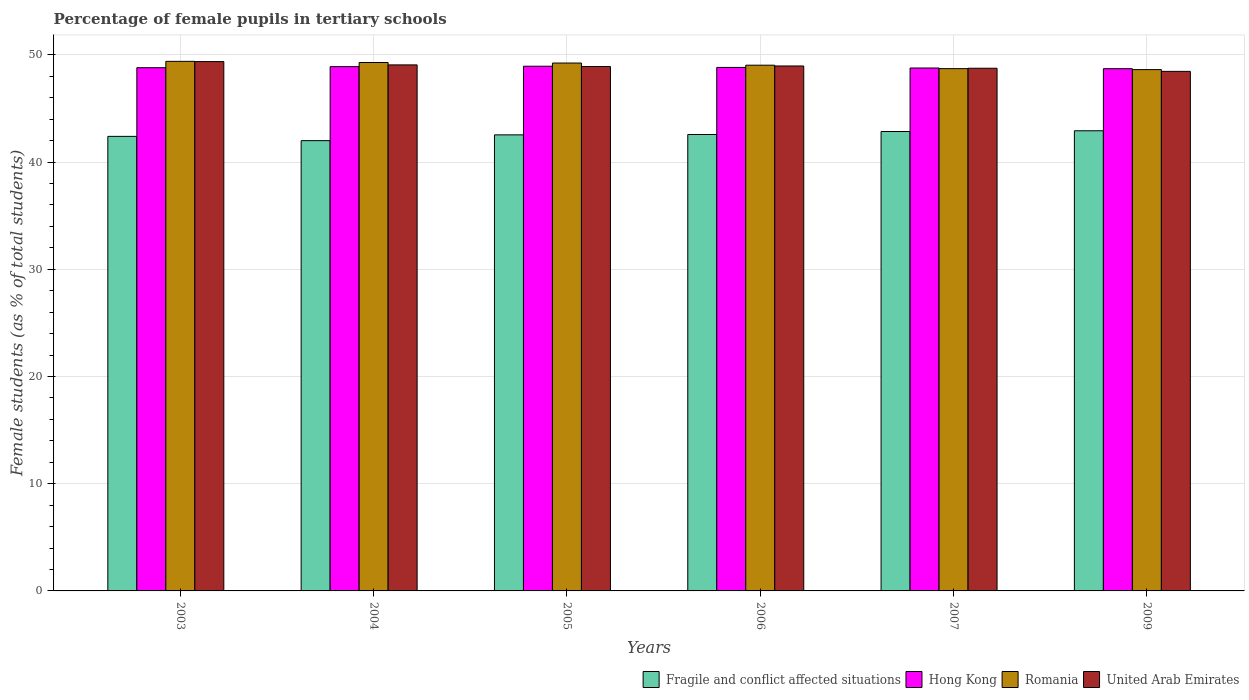How many groups of bars are there?
Keep it short and to the point. 6. Are the number of bars on each tick of the X-axis equal?
Offer a terse response. Yes. How many bars are there on the 3rd tick from the right?
Provide a succinct answer. 4. What is the percentage of female pupils in tertiary schools in Fragile and conflict affected situations in 2005?
Offer a very short reply. 42.53. Across all years, what is the maximum percentage of female pupils in tertiary schools in Romania?
Provide a succinct answer. 49.39. Across all years, what is the minimum percentage of female pupils in tertiary schools in Romania?
Make the answer very short. 48.62. In which year was the percentage of female pupils in tertiary schools in Romania maximum?
Provide a succinct answer. 2003. In which year was the percentage of female pupils in tertiary schools in United Arab Emirates minimum?
Offer a very short reply. 2009. What is the total percentage of female pupils in tertiary schools in Romania in the graph?
Your answer should be very brief. 294.27. What is the difference between the percentage of female pupils in tertiary schools in Hong Kong in 2006 and that in 2007?
Make the answer very short. 0.06. What is the difference between the percentage of female pupils in tertiary schools in United Arab Emirates in 2003 and the percentage of female pupils in tertiary schools in Fragile and conflict affected situations in 2005?
Your answer should be compact. 6.83. What is the average percentage of female pupils in tertiary schools in Romania per year?
Provide a short and direct response. 49.04. In the year 2004, what is the difference between the percentage of female pupils in tertiary schools in Fragile and conflict affected situations and percentage of female pupils in tertiary schools in Hong Kong?
Ensure brevity in your answer.  -6.9. In how many years, is the percentage of female pupils in tertiary schools in Fragile and conflict affected situations greater than 48 %?
Your answer should be compact. 0. What is the ratio of the percentage of female pupils in tertiary schools in Romania in 2003 to that in 2009?
Ensure brevity in your answer.  1.02. Is the percentage of female pupils in tertiary schools in Fragile and conflict affected situations in 2003 less than that in 2009?
Keep it short and to the point. Yes. What is the difference between the highest and the second highest percentage of female pupils in tertiary schools in Fragile and conflict affected situations?
Offer a very short reply. 0.07. What is the difference between the highest and the lowest percentage of female pupils in tertiary schools in Romania?
Your answer should be very brief. 0.77. Is the sum of the percentage of female pupils in tertiary schools in United Arab Emirates in 2006 and 2007 greater than the maximum percentage of female pupils in tertiary schools in Hong Kong across all years?
Provide a short and direct response. Yes. What does the 3rd bar from the left in 2007 represents?
Your answer should be very brief. Romania. What does the 2nd bar from the right in 2004 represents?
Provide a succinct answer. Romania. How many bars are there?
Make the answer very short. 24. Are all the bars in the graph horizontal?
Your response must be concise. No. Does the graph contain any zero values?
Ensure brevity in your answer.  No. Does the graph contain grids?
Your response must be concise. Yes. Where does the legend appear in the graph?
Give a very brief answer. Bottom right. How many legend labels are there?
Keep it short and to the point. 4. What is the title of the graph?
Offer a terse response. Percentage of female pupils in tertiary schools. What is the label or title of the X-axis?
Your answer should be very brief. Years. What is the label or title of the Y-axis?
Offer a very short reply. Female students (as % of total students). What is the Female students (as % of total students) in Fragile and conflict affected situations in 2003?
Your response must be concise. 42.39. What is the Female students (as % of total students) of Hong Kong in 2003?
Provide a short and direct response. 48.8. What is the Female students (as % of total students) in Romania in 2003?
Provide a succinct answer. 49.39. What is the Female students (as % of total students) in United Arab Emirates in 2003?
Give a very brief answer. 49.37. What is the Female students (as % of total students) in Fragile and conflict affected situations in 2004?
Provide a succinct answer. 42. What is the Female students (as % of total students) in Hong Kong in 2004?
Ensure brevity in your answer.  48.9. What is the Female students (as % of total students) in Romania in 2004?
Make the answer very short. 49.28. What is the Female students (as % of total students) in United Arab Emirates in 2004?
Your response must be concise. 49.06. What is the Female students (as % of total students) in Fragile and conflict affected situations in 2005?
Your answer should be compact. 42.53. What is the Female students (as % of total students) in Hong Kong in 2005?
Offer a very short reply. 48.94. What is the Female students (as % of total students) in Romania in 2005?
Offer a terse response. 49.23. What is the Female students (as % of total students) in United Arab Emirates in 2005?
Your answer should be very brief. 48.91. What is the Female students (as % of total students) in Fragile and conflict affected situations in 2006?
Offer a terse response. 42.57. What is the Female students (as % of total students) in Hong Kong in 2006?
Make the answer very short. 48.82. What is the Female students (as % of total students) in Romania in 2006?
Offer a very short reply. 49.03. What is the Female students (as % of total students) of United Arab Emirates in 2006?
Make the answer very short. 48.96. What is the Female students (as % of total students) in Fragile and conflict affected situations in 2007?
Your answer should be compact. 42.85. What is the Female students (as % of total students) in Hong Kong in 2007?
Your response must be concise. 48.77. What is the Female students (as % of total students) of Romania in 2007?
Offer a very short reply. 48.71. What is the Female students (as % of total students) in United Arab Emirates in 2007?
Ensure brevity in your answer.  48.75. What is the Female students (as % of total students) of Fragile and conflict affected situations in 2009?
Your answer should be compact. 42.92. What is the Female students (as % of total students) of Hong Kong in 2009?
Make the answer very short. 48.71. What is the Female students (as % of total students) in Romania in 2009?
Provide a short and direct response. 48.62. What is the Female students (as % of total students) in United Arab Emirates in 2009?
Provide a succinct answer. 48.46. Across all years, what is the maximum Female students (as % of total students) of Fragile and conflict affected situations?
Your response must be concise. 42.92. Across all years, what is the maximum Female students (as % of total students) of Hong Kong?
Keep it short and to the point. 48.94. Across all years, what is the maximum Female students (as % of total students) in Romania?
Keep it short and to the point. 49.39. Across all years, what is the maximum Female students (as % of total students) of United Arab Emirates?
Offer a very short reply. 49.37. Across all years, what is the minimum Female students (as % of total students) of Fragile and conflict affected situations?
Offer a very short reply. 42. Across all years, what is the minimum Female students (as % of total students) in Hong Kong?
Your response must be concise. 48.71. Across all years, what is the minimum Female students (as % of total students) in Romania?
Provide a short and direct response. 48.62. Across all years, what is the minimum Female students (as % of total students) in United Arab Emirates?
Ensure brevity in your answer.  48.46. What is the total Female students (as % of total students) of Fragile and conflict affected situations in the graph?
Offer a very short reply. 255.25. What is the total Female students (as % of total students) in Hong Kong in the graph?
Make the answer very short. 292.93. What is the total Female students (as % of total students) of Romania in the graph?
Provide a succinct answer. 294.27. What is the total Female students (as % of total students) of United Arab Emirates in the graph?
Your response must be concise. 293.5. What is the difference between the Female students (as % of total students) of Fragile and conflict affected situations in 2003 and that in 2004?
Offer a very short reply. 0.4. What is the difference between the Female students (as % of total students) of Hong Kong in 2003 and that in 2004?
Your response must be concise. -0.1. What is the difference between the Female students (as % of total students) of Romania in 2003 and that in 2004?
Your answer should be compact. 0.11. What is the difference between the Female students (as % of total students) of United Arab Emirates in 2003 and that in 2004?
Offer a very short reply. 0.31. What is the difference between the Female students (as % of total students) in Fragile and conflict affected situations in 2003 and that in 2005?
Offer a very short reply. -0.14. What is the difference between the Female students (as % of total students) of Hong Kong in 2003 and that in 2005?
Your answer should be very brief. -0.14. What is the difference between the Female students (as % of total students) of Romania in 2003 and that in 2005?
Give a very brief answer. 0.16. What is the difference between the Female students (as % of total students) of United Arab Emirates in 2003 and that in 2005?
Give a very brief answer. 0.46. What is the difference between the Female students (as % of total students) in Fragile and conflict affected situations in 2003 and that in 2006?
Make the answer very short. -0.17. What is the difference between the Female students (as % of total students) in Hong Kong in 2003 and that in 2006?
Your answer should be very brief. -0.03. What is the difference between the Female students (as % of total students) of Romania in 2003 and that in 2006?
Offer a very short reply. 0.36. What is the difference between the Female students (as % of total students) in United Arab Emirates in 2003 and that in 2006?
Give a very brief answer. 0.41. What is the difference between the Female students (as % of total students) in Fragile and conflict affected situations in 2003 and that in 2007?
Provide a short and direct response. -0.45. What is the difference between the Female students (as % of total students) of Hong Kong in 2003 and that in 2007?
Give a very brief answer. 0.03. What is the difference between the Female students (as % of total students) of Romania in 2003 and that in 2007?
Provide a succinct answer. 0.68. What is the difference between the Female students (as % of total students) of United Arab Emirates in 2003 and that in 2007?
Keep it short and to the point. 0.62. What is the difference between the Female students (as % of total students) of Fragile and conflict affected situations in 2003 and that in 2009?
Keep it short and to the point. -0.52. What is the difference between the Female students (as % of total students) in Hong Kong in 2003 and that in 2009?
Ensure brevity in your answer.  0.09. What is the difference between the Female students (as % of total students) in Romania in 2003 and that in 2009?
Your response must be concise. 0.77. What is the difference between the Female students (as % of total students) of United Arab Emirates in 2003 and that in 2009?
Provide a short and direct response. 0.91. What is the difference between the Female students (as % of total students) of Fragile and conflict affected situations in 2004 and that in 2005?
Your answer should be very brief. -0.54. What is the difference between the Female students (as % of total students) of Hong Kong in 2004 and that in 2005?
Provide a short and direct response. -0.04. What is the difference between the Female students (as % of total students) in Romania in 2004 and that in 2005?
Provide a short and direct response. 0.05. What is the difference between the Female students (as % of total students) in United Arab Emirates in 2004 and that in 2005?
Give a very brief answer. 0.15. What is the difference between the Female students (as % of total students) of Fragile and conflict affected situations in 2004 and that in 2006?
Make the answer very short. -0.57. What is the difference between the Female students (as % of total students) in Hong Kong in 2004 and that in 2006?
Make the answer very short. 0.07. What is the difference between the Female students (as % of total students) in Romania in 2004 and that in 2006?
Your answer should be very brief. 0.25. What is the difference between the Female students (as % of total students) of United Arab Emirates in 2004 and that in 2006?
Your answer should be very brief. 0.1. What is the difference between the Female students (as % of total students) in Fragile and conflict affected situations in 2004 and that in 2007?
Provide a short and direct response. -0.85. What is the difference between the Female students (as % of total students) in Hong Kong in 2004 and that in 2007?
Keep it short and to the point. 0.13. What is the difference between the Female students (as % of total students) in Romania in 2004 and that in 2007?
Ensure brevity in your answer.  0.57. What is the difference between the Female students (as % of total students) in United Arab Emirates in 2004 and that in 2007?
Provide a short and direct response. 0.31. What is the difference between the Female students (as % of total students) of Fragile and conflict affected situations in 2004 and that in 2009?
Keep it short and to the point. -0.92. What is the difference between the Female students (as % of total students) in Hong Kong in 2004 and that in 2009?
Ensure brevity in your answer.  0.19. What is the difference between the Female students (as % of total students) of Romania in 2004 and that in 2009?
Give a very brief answer. 0.66. What is the difference between the Female students (as % of total students) of United Arab Emirates in 2004 and that in 2009?
Provide a short and direct response. 0.6. What is the difference between the Female students (as % of total students) of Fragile and conflict affected situations in 2005 and that in 2006?
Provide a short and direct response. -0.04. What is the difference between the Female students (as % of total students) in Hong Kong in 2005 and that in 2006?
Your response must be concise. 0.11. What is the difference between the Female students (as % of total students) in Romania in 2005 and that in 2006?
Keep it short and to the point. 0.2. What is the difference between the Female students (as % of total students) of United Arab Emirates in 2005 and that in 2006?
Provide a short and direct response. -0.05. What is the difference between the Female students (as % of total students) of Fragile and conflict affected situations in 2005 and that in 2007?
Your answer should be very brief. -0.31. What is the difference between the Female students (as % of total students) in Hong Kong in 2005 and that in 2007?
Offer a very short reply. 0.17. What is the difference between the Female students (as % of total students) of Romania in 2005 and that in 2007?
Provide a short and direct response. 0.52. What is the difference between the Female students (as % of total students) in United Arab Emirates in 2005 and that in 2007?
Provide a short and direct response. 0.16. What is the difference between the Female students (as % of total students) of Fragile and conflict affected situations in 2005 and that in 2009?
Offer a terse response. -0.38. What is the difference between the Female students (as % of total students) of Hong Kong in 2005 and that in 2009?
Keep it short and to the point. 0.23. What is the difference between the Female students (as % of total students) in Romania in 2005 and that in 2009?
Make the answer very short. 0.61. What is the difference between the Female students (as % of total students) in United Arab Emirates in 2005 and that in 2009?
Provide a short and direct response. 0.45. What is the difference between the Female students (as % of total students) in Fragile and conflict affected situations in 2006 and that in 2007?
Keep it short and to the point. -0.28. What is the difference between the Female students (as % of total students) in Hong Kong in 2006 and that in 2007?
Provide a short and direct response. 0.06. What is the difference between the Female students (as % of total students) in Romania in 2006 and that in 2007?
Keep it short and to the point. 0.32. What is the difference between the Female students (as % of total students) of United Arab Emirates in 2006 and that in 2007?
Your answer should be very brief. 0.21. What is the difference between the Female students (as % of total students) of Fragile and conflict affected situations in 2006 and that in 2009?
Offer a very short reply. -0.35. What is the difference between the Female students (as % of total students) in Hong Kong in 2006 and that in 2009?
Provide a short and direct response. 0.12. What is the difference between the Female students (as % of total students) in Romania in 2006 and that in 2009?
Ensure brevity in your answer.  0.41. What is the difference between the Female students (as % of total students) in United Arab Emirates in 2006 and that in 2009?
Give a very brief answer. 0.5. What is the difference between the Female students (as % of total students) in Fragile and conflict affected situations in 2007 and that in 2009?
Offer a terse response. -0.07. What is the difference between the Female students (as % of total students) of Hong Kong in 2007 and that in 2009?
Offer a very short reply. 0.06. What is the difference between the Female students (as % of total students) in Romania in 2007 and that in 2009?
Offer a very short reply. 0.09. What is the difference between the Female students (as % of total students) of United Arab Emirates in 2007 and that in 2009?
Provide a short and direct response. 0.29. What is the difference between the Female students (as % of total students) of Fragile and conflict affected situations in 2003 and the Female students (as % of total students) of Hong Kong in 2004?
Give a very brief answer. -6.5. What is the difference between the Female students (as % of total students) of Fragile and conflict affected situations in 2003 and the Female students (as % of total students) of Romania in 2004?
Offer a terse response. -6.89. What is the difference between the Female students (as % of total students) of Fragile and conflict affected situations in 2003 and the Female students (as % of total students) of United Arab Emirates in 2004?
Your answer should be compact. -6.67. What is the difference between the Female students (as % of total students) of Hong Kong in 2003 and the Female students (as % of total students) of Romania in 2004?
Keep it short and to the point. -0.48. What is the difference between the Female students (as % of total students) of Hong Kong in 2003 and the Female students (as % of total students) of United Arab Emirates in 2004?
Offer a very short reply. -0.26. What is the difference between the Female students (as % of total students) in Romania in 2003 and the Female students (as % of total students) in United Arab Emirates in 2004?
Ensure brevity in your answer.  0.33. What is the difference between the Female students (as % of total students) in Fragile and conflict affected situations in 2003 and the Female students (as % of total students) in Hong Kong in 2005?
Make the answer very short. -6.54. What is the difference between the Female students (as % of total students) of Fragile and conflict affected situations in 2003 and the Female students (as % of total students) of Romania in 2005?
Give a very brief answer. -6.84. What is the difference between the Female students (as % of total students) in Fragile and conflict affected situations in 2003 and the Female students (as % of total students) in United Arab Emirates in 2005?
Offer a terse response. -6.51. What is the difference between the Female students (as % of total students) in Hong Kong in 2003 and the Female students (as % of total students) in Romania in 2005?
Provide a short and direct response. -0.43. What is the difference between the Female students (as % of total students) of Hong Kong in 2003 and the Female students (as % of total students) of United Arab Emirates in 2005?
Offer a very short reply. -0.11. What is the difference between the Female students (as % of total students) of Romania in 2003 and the Female students (as % of total students) of United Arab Emirates in 2005?
Give a very brief answer. 0.48. What is the difference between the Female students (as % of total students) of Fragile and conflict affected situations in 2003 and the Female students (as % of total students) of Hong Kong in 2006?
Give a very brief answer. -6.43. What is the difference between the Female students (as % of total students) of Fragile and conflict affected situations in 2003 and the Female students (as % of total students) of Romania in 2006?
Your answer should be very brief. -6.64. What is the difference between the Female students (as % of total students) of Fragile and conflict affected situations in 2003 and the Female students (as % of total students) of United Arab Emirates in 2006?
Keep it short and to the point. -6.57. What is the difference between the Female students (as % of total students) of Hong Kong in 2003 and the Female students (as % of total students) of Romania in 2006?
Your answer should be compact. -0.23. What is the difference between the Female students (as % of total students) in Hong Kong in 2003 and the Female students (as % of total students) in United Arab Emirates in 2006?
Give a very brief answer. -0.16. What is the difference between the Female students (as % of total students) of Romania in 2003 and the Female students (as % of total students) of United Arab Emirates in 2006?
Your response must be concise. 0.43. What is the difference between the Female students (as % of total students) of Fragile and conflict affected situations in 2003 and the Female students (as % of total students) of Hong Kong in 2007?
Your response must be concise. -6.38. What is the difference between the Female students (as % of total students) of Fragile and conflict affected situations in 2003 and the Female students (as % of total students) of Romania in 2007?
Your response must be concise. -6.32. What is the difference between the Female students (as % of total students) in Fragile and conflict affected situations in 2003 and the Female students (as % of total students) in United Arab Emirates in 2007?
Make the answer very short. -6.35. What is the difference between the Female students (as % of total students) in Hong Kong in 2003 and the Female students (as % of total students) in Romania in 2007?
Ensure brevity in your answer.  0.09. What is the difference between the Female students (as % of total students) of Hong Kong in 2003 and the Female students (as % of total students) of United Arab Emirates in 2007?
Make the answer very short. 0.05. What is the difference between the Female students (as % of total students) in Romania in 2003 and the Female students (as % of total students) in United Arab Emirates in 2007?
Give a very brief answer. 0.64. What is the difference between the Female students (as % of total students) of Fragile and conflict affected situations in 2003 and the Female students (as % of total students) of Hong Kong in 2009?
Provide a succinct answer. -6.31. What is the difference between the Female students (as % of total students) in Fragile and conflict affected situations in 2003 and the Female students (as % of total students) in Romania in 2009?
Make the answer very short. -6.23. What is the difference between the Female students (as % of total students) in Fragile and conflict affected situations in 2003 and the Female students (as % of total students) in United Arab Emirates in 2009?
Offer a very short reply. -6.06. What is the difference between the Female students (as % of total students) of Hong Kong in 2003 and the Female students (as % of total students) of Romania in 2009?
Make the answer very short. 0.18. What is the difference between the Female students (as % of total students) in Hong Kong in 2003 and the Female students (as % of total students) in United Arab Emirates in 2009?
Ensure brevity in your answer.  0.34. What is the difference between the Female students (as % of total students) of Romania in 2003 and the Female students (as % of total students) of United Arab Emirates in 2009?
Your answer should be compact. 0.93. What is the difference between the Female students (as % of total students) in Fragile and conflict affected situations in 2004 and the Female students (as % of total students) in Hong Kong in 2005?
Give a very brief answer. -6.94. What is the difference between the Female students (as % of total students) in Fragile and conflict affected situations in 2004 and the Female students (as % of total students) in Romania in 2005?
Offer a terse response. -7.24. What is the difference between the Female students (as % of total students) in Fragile and conflict affected situations in 2004 and the Female students (as % of total students) in United Arab Emirates in 2005?
Make the answer very short. -6.91. What is the difference between the Female students (as % of total students) in Hong Kong in 2004 and the Female students (as % of total students) in Romania in 2005?
Your answer should be compact. -0.34. What is the difference between the Female students (as % of total students) of Hong Kong in 2004 and the Female students (as % of total students) of United Arab Emirates in 2005?
Provide a short and direct response. -0.01. What is the difference between the Female students (as % of total students) of Romania in 2004 and the Female students (as % of total students) of United Arab Emirates in 2005?
Offer a terse response. 0.37. What is the difference between the Female students (as % of total students) in Fragile and conflict affected situations in 2004 and the Female students (as % of total students) in Hong Kong in 2006?
Your answer should be very brief. -6.83. What is the difference between the Female students (as % of total students) of Fragile and conflict affected situations in 2004 and the Female students (as % of total students) of Romania in 2006?
Your answer should be very brief. -7.04. What is the difference between the Female students (as % of total students) of Fragile and conflict affected situations in 2004 and the Female students (as % of total students) of United Arab Emirates in 2006?
Make the answer very short. -6.96. What is the difference between the Female students (as % of total students) in Hong Kong in 2004 and the Female students (as % of total students) in Romania in 2006?
Make the answer very short. -0.13. What is the difference between the Female students (as % of total students) of Hong Kong in 2004 and the Female students (as % of total students) of United Arab Emirates in 2006?
Your answer should be compact. -0.06. What is the difference between the Female students (as % of total students) in Romania in 2004 and the Female students (as % of total students) in United Arab Emirates in 2006?
Offer a very short reply. 0.32. What is the difference between the Female students (as % of total students) in Fragile and conflict affected situations in 2004 and the Female students (as % of total students) in Hong Kong in 2007?
Offer a terse response. -6.77. What is the difference between the Female students (as % of total students) of Fragile and conflict affected situations in 2004 and the Female students (as % of total students) of Romania in 2007?
Provide a succinct answer. -6.72. What is the difference between the Female students (as % of total students) in Fragile and conflict affected situations in 2004 and the Female students (as % of total students) in United Arab Emirates in 2007?
Your answer should be very brief. -6.75. What is the difference between the Female students (as % of total students) in Hong Kong in 2004 and the Female students (as % of total students) in Romania in 2007?
Your response must be concise. 0.19. What is the difference between the Female students (as % of total students) of Hong Kong in 2004 and the Female students (as % of total students) of United Arab Emirates in 2007?
Provide a short and direct response. 0.15. What is the difference between the Female students (as % of total students) in Romania in 2004 and the Female students (as % of total students) in United Arab Emirates in 2007?
Ensure brevity in your answer.  0.53. What is the difference between the Female students (as % of total students) in Fragile and conflict affected situations in 2004 and the Female students (as % of total students) in Hong Kong in 2009?
Provide a short and direct response. -6.71. What is the difference between the Female students (as % of total students) of Fragile and conflict affected situations in 2004 and the Female students (as % of total students) of Romania in 2009?
Provide a succinct answer. -6.63. What is the difference between the Female students (as % of total students) of Fragile and conflict affected situations in 2004 and the Female students (as % of total students) of United Arab Emirates in 2009?
Offer a terse response. -6.46. What is the difference between the Female students (as % of total students) in Hong Kong in 2004 and the Female students (as % of total students) in Romania in 2009?
Your response must be concise. 0.28. What is the difference between the Female students (as % of total students) in Hong Kong in 2004 and the Female students (as % of total students) in United Arab Emirates in 2009?
Your answer should be compact. 0.44. What is the difference between the Female students (as % of total students) in Romania in 2004 and the Female students (as % of total students) in United Arab Emirates in 2009?
Ensure brevity in your answer.  0.83. What is the difference between the Female students (as % of total students) in Fragile and conflict affected situations in 2005 and the Female students (as % of total students) in Hong Kong in 2006?
Provide a short and direct response. -6.29. What is the difference between the Female students (as % of total students) in Fragile and conflict affected situations in 2005 and the Female students (as % of total students) in Romania in 2006?
Give a very brief answer. -6.5. What is the difference between the Female students (as % of total students) in Fragile and conflict affected situations in 2005 and the Female students (as % of total students) in United Arab Emirates in 2006?
Make the answer very short. -6.43. What is the difference between the Female students (as % of total students) in Hong Kong in 2005 and the Female students (as % of total students) in Romania in 2006?
Your answer should be very brief. -0.1. What is the difference between the Female students (as % of total students) of Hong Kong in 2005 and the Female students (as % of total students) of United Arab Emirates in 2006?
Provide a succinct answer. -0.02. What is the difference between the Female students (as % of total students) in Romania in 2005 and the Female students (as % of total students) in United Arab Emirates in 2006?
Your answer should be compact. 0.27. What is the difference between the Female students (as % of total students) in Fragile and conflict affected situations in 2005 and the Female students (as % of total students) in Hong Kong in 2007?
Your answer should be very brief. -6.24. What is the difference between the Female students (as % of total students) in Fragile and conflict affected situations in 2005 and the Female students (as % of total students) in Romania in 2007?
Ensure brevity in your answer.  -6.18. What is the difference between the Female students (as % of total students) in Fragile and conflict affected situations in 2005 and the Female students (as % of total students) in United Arab Emirates in 2007?
Your answer should be very brief. -6.21. What is the difference between the Female students (as % of total students) in Hong Kong in 2005 and the Female students (as % of total students) in Romania in 2007?
Provide a succinct answer. 0.23. What is the difference between the Female students (as % of total students) of Hong Kong in 2005 and the Female students (as % of total students) of United Arab Emirates in 2007?
Your response must be concise. 0.19. What is the difference between the Female students (as % of total students) in Romania in 2005 and the Female students (as % of total students) in United Arab Emirates in 2007?
Make the answer very short. 0.48. What is the difference between the Female students (as % of total students) of Fragile and conflict affected situations in 2005 and the Female students (as % of total students) of Hong Kong in 2009?
Your answer should be very brief. -6.17. What is the difference between the Female students (as % of total students) of Fragile and conflict affected situations in 2005 and the Female students (as % of total students) of Romania in 2009?
Provide a succinct answer. -6.09. What is the difference between the Female students (as % of total students) in Fragile and conflict affected situations in 2005 and the Female students (as % of total students) in United Arab Emirates in 2009?
Provide a short and direct response. -5.92. What is the difference between the Female students (as % of total students) of Hong Kong in 2005 and the Female students (as % of total students) of Romania in 2009?
Offer a very short reply. 0.32. What is the difference between the Female students (as % of total students) in Hong Kong in 2005 and the Female students (as % of total students) in United Arab Emirates in 2009?
Offer a very short reply. 0.48. What is the difference between the Female students (as % of total students) of Romania in 2005 and the Female students (as % of total students) of United Arab Emirates in 2009?
Provide a succinct answer. 0.78. What is the difference between the Female students (as % of total students) of Fragile and conflict affected situations in 2006 and the Female students (as % of total students) of Hong Kong in 2007?
Make the answer very short. -6.2. What is the difference between the Female students (as % of total students) in Fragile and conflict affected situations in 2006 and the Female students (as % of total students) in Romania in 2007?
Offer a very short reply. -6.14. What is the difference between the Female students (as % of total students) of Fragile and conflict affected situations in 2006 and the Female students (as % of total students) of United Arab Emirates in 2007?
Ensure brevity in your answer.  -6.18. What is the difference between the Female students (as % of total students) in Hong Kong in 2006 and the Female students (as % of total students) in Romania in 2007?
Your answer should be very brief. 0.11. What is the difference between the Female students (as % of total students) in Hong Kong in 2006 and the Female students (as % of total students) in United Arab Emirates in 2007?
Provide a succinct answer. 0.08. What is the difference between the Female students (as % of total students) of Romania in 2006 and the Female students (as % of total students) of United Arab Emirates in 2007?
Ensure brevity in your answer.  0.28. What is the difference between the Female students (as % of total students) of Fragile and conflict affected situations in 2006 and the Female students (as % of total students) of Hong Kong in 2009?
Your response must be concise. -6.14. What is the difference between the Female students (as % of total students) of Fragile and conflict affected situations in 2006 and the Female students (as % of total students) of Romania in 2009?
Ensure brevity in your answer.  -6.05. What is the difference between the Female students (as % of total students) in Fragile and conflict affected situations in 2006 and the Female students (as % of total students) in United Arab Emirates in 2009?
Give a very brief answer. -5.89. What is the difference between the Female students (as % of total students) in Hong Kong in 2006 and the Female students (as % of total students) in Romania in 2009?
Your answer should be compact. 0.2. What is the difference between the Female students (as % of total students) in Hong Kong in 2006 and the Female students (as % of total students) in United Arab Emirates in 2009?
Your answer should be compact. 0.37. What is the difference between the Female students (as % of total students) of Romania in 2006 and the Female students (as % of total students) of United Arab Emirates in 2009?
Provide a succinct answer. 0.58. What is the difference between the Female students (as % of total students) in Fragile and conflict affected situations in 2007 and the Female students (as % of total students) in Hong Kong in 2009?
Make the answer very short. -5.86. What is the difference between the Female students (as % of total students) in Fragile and conflict affected situations in 2007 and the Female students (as % of total students) in Romania in 2009?
Keep it short and to the point. -5.77. What is the difference between the Female students (as % of total students) in Fragile and conflict affected situations in 2007 and the Female students (as % of total students) in United Arab Emirates in 2009?
Provide a short and direct response. -5.61. What is the difference between the Female students (as % of total students) in Hong Kong in 2007 and the Female students (as % of total students) in Romania in 2009?
Provide a succinct answer. 0.15. What is the difference between the Female students (as % of total students) in Hong Kong in 2007 and the Female students (as % of total students) in United Arab Emirates in 2009?
Provide a short and direct response. 0.31. What is the difference between the Female students (as % of total students) of Romania in 2007 and the Female students (as % of total students) of United Arab Emirates in 2009?
Offer a very short reply. 0.25. What is the average Female students (as % of total students) in Fragile and conflict affected situations per year?
Offer a very short reply. 42.54. What is the average Female students (as % of total students) in Hong Kong per year?
Your answer should be very brief. 48.82. What is the average Female students (as % of total students) in Romania per year?
Offer a very short reply. 49.04. What is the average Female students (as % of total students) in United Arab Emirates per year?
Give a very brief answer. 48.92. In the year 2003, what is the difference between the Female students (as % of total students) in Fragile and conflict affected situations and Female students (as % of total students) in Hong Kong?
Give a very brief answer. -6.4. In the year 2003, what is the difference between the Female students (as % of total students) of Fragile and conflict affected situations and Female students (as % of total students) of Romania?
Your answer should be very brief. -7. In the year 2003, what is the difference between the Female students (as % of total students) in Fragile and conflict affected situations and Female students (as % of total students) in United Arab Emirates?
Your answer should be compact. -6.97. In the year 2003, what is the difference between the Female students (as % of total students) of Hong Kong and Female students (as % of total students) of Romania?
Your response must be concise. -0.59. In the year 2003, what is the difference between the Female students (as % of total students) of Hong Kong and Female students (as % of total students) of United Arab Emirates?
Your answer should be very brief. -0.57. In the year 2003, what is the difference between the Female students (as % of total students) of Romania and Female students (as % of total students) of United Arab Emirates?
Give a very brief answer. 0.02. In the year 2004, what is the difference between the Female students (as % of total students) in Fragile and conflict affected situations and Female students (as % of total students) in Hong Kong?
Provide a short and direct response. -6.9. In the year 2004, what is the difference between the Female students (as % of total students) in Fragile and conflict affected situations and Female students (as % of total students) in Romania?
Your response must be concise. -7.29. In the year 2004, what is the difference between the Female students (as % of total students) in Fragile and conflict affected situations and Female students (as % of total students) in United Arab Emirates?
Give a very brief answer. -7.06. In the year 2004, what is the difference between the Female students (as % of total students) in Hong Kong and Female students (as % of total students) in Romania?
Your answer should be very brief. -0.38. In the year 2004, what is the difference between the Female students (as % of total students) in Hong Kong and Female students (as % of total students) in United Arab Emirates?
Your answer should be very brief. -0.16. In the year 2004, what is the difference between the Female students (as % of total students) of Romania and Female students (as % of total students) of United Arab Emirates?
Your response must be concise. 0.22. In the year 2005, what is the difference between the Female students (as % of total students) in Fragile and conflict affected situations and Female students (as % of total students) in Hong Kong?
Give a very brief answer. -6.4. In the year 2005, what is the difference between the Female students (as % of total students) in Fragile and conflict affected situations and Female students (as % of total students) in Romania?
Your answer should be very brief. -6.7. In the year 2005, what is the difference between the Female students (as % of total students) in Fragile and conflict affected situations and Female students (as % of total students) in United Arab Emirates?
Your answer should be compact. -6.37. In the year 2005, what is the difference between the Female students (as % of total students) of Hong Kong and Female students (as % of total students) of Romania?
Offer a very short reply. -0.3. In the year 2005, what is the difference between the Female students (as % of total students) of Hong Kong and Female students (as % of total students) of United Arab Emirates?
Offer a terse response. 0.03. In the year 2005, what is the difference between the Female students (as % of total students) in Romania and Female students (as % of total students) in United Arab Emirates?
Give a very brief answer. 0.32. In the year 2006, what is the difference between the Female students (as % of total students) of Fragile and conflict affected situations and Female students (as % of total students) of Hong Kong?
Provide a succinct answer. -6.26. In the year 2006, what is the difference between the Female students (as % of total students) in Fragile and conflict affected situations and Female students (as % of total students) in Romania?
Offer a terse response. -6.46. In the year 2006, what is the difference between the Female students (as % of total students) of Fragile and conflict affected situations and Female students (as % of total students) of United Arab Emirates?
Provide a short and direct response. -6.39. In the year 2006, what is the difference between the Female students (as % of total students) of Hong Kong and Female students (as % of total students) of Romania?
Your response must be concise. -0.21. In the year 2006, what is the difference between the Female students (as % of total students) in Hong Kong and Female students (as % of total students) in United Arab Emirates?
Ensure brevity in your answer.  -0.13. In the year 2006, what is the difference between the Female students (as % of total students) of Romania and Female students (as % of total students) of United Arab Emirates?
Give a very brief answer. 0.07. In the year 2007, what is the difference between the Female students (as % of total students) of Fragile and conflict affected situations and Female students (as % of total students) of Hong Kong?
Make the answer very short. -5.92. In the year 2007, what is the difference between the Female students (as % of total students) in Fragile and conflict affected situations and Female students (as % of total students) in Romania?
Your response must be concise. -5.86. In the year 2007, what is the difference between the Female students (as % of total students) of Fragile and conflict affected situations and Female students (as % of total students) of United Arab Emirates?
Provide a short and direct response. -5.9. In the year 2007, what is the difference between the Female students (as % of total students) in Hong Kong and Female students (as % of total students) in Romania?
Offer a very short reply. 0.06. In the year 2007, what is the difference between the Female students (as % of total students) of Hong Kong and Female students (as % of total students) of United Arab Emirates?
Offer a very short reply. 0.02. In the year 2007, what is the difference between the Female students (as % of total students) of Romania and Female students (as % of total students) of United Arab Emirates?
Provide a short and direct response. -0.04. In the year 2009, what is the difference between the Female students (as % of total students) of Fragile and conflict affected situations and Female students (as % of total students) of Hong Kong?
Your answer should be very brief. -5.79. In the year 2009, what is the difference between the Female students (as % of total students) in Fragile and conflict affected situations and Female students (as % of total students) in Romania?
Provide a short and direct response. -5.71. In the year 2009, what is the difference between the Female students (as % of total students) in Fragile and conflict affected situations and Female students (as % of total students) in United Arab Emirates?
Your answer should be very brief. -5.54. In the year 2009, what is the difference between the Female students (as % of total students) in Hong Kong and Female students (as % of total students) in Romania?
Provide a succinct answer. 0.08. In the year 2009, what is the difference between the Female students (as % of total students) in Hong Kong and Female students (as % of total students) in United Arab Emirates?
Your response must be concise. 0.25. In the year 2009, what is the difference between the Female students (as % of total students) in Romania and Female students (as % of total students) in United Arab Emirates?
Provide a short and direct response. 0.16. What is the ratio of the Female students (as % of total students) in Fragile and conflict affected situations in 2003 to that in 2004?
Keep it short and to the point. 1.01. What is the ratio of the Female students (as % of total students) in Romania in 2003 to that in 2004?
Make the answer very short. 1. What is the ratio of the Female students (as % of total students) in Fragile and conflict affected situations in 2003 to that in 2005?
Your answer should be compact. 1. What is the ratio of the Female students (as % of total students) of Romania in 2003 to that in 2005?
Your answer should be very brief. 1. What is the ratio of the Female students (as % of total students) of United Arab Emirates in 2003 to that in 2005?
Your response must be concise. 1.01. What is the ratio of the Female students (as % of total students) in Hong Kong in 2003 to that in 2006?
Offer a very short reply. 1. What is the ratio of the Female students (as % of total students) in Romania in 2003 to that in 2006?
Your answer should be compact. 1.01. What is the ratio of the Female students (as % of total students) of United Arab Emirates in 2003 to that in 2006?
Offer a very short reply. 1.01. What is the ratio of the Female students (as % of total students) in United Arab Emirates in 2003 to that in 2007?
Keep it short and to the point. 1.01. What is the ratio of the Female students (as % of total students) of Fragile and conflict affected situations in 2003 to that in 2009?
Offer a very short reply. 0.99. What is the ratio of the Female students (as % of total students) in Hong Kong in 2003 to that in 2009?
Make the answer very short. 1. What is the ratio of the Female students (as % of total students) in Romania in 2003 to that in 2009?
Give a very brief answer. 1.02. What is the ratio of the Female students (as % of total students) of United Arab Emirates in 2003 to that in 2009?
Your answer should be very brief. 1.02. What is the ratio of the Female students (as % of total students) in Fragile and conflict affected situations in 2004 to that in 2005?
Your answer should be very brief. 0.99. What is the ratio of the Female students (as % of total students) of Hong Kong in 2004 to that in 2005?
Your response must be concise. 1. What is the ratio of the Female students (as % of total students) in United Arab Emirates in 2004 to that in 2005?
Give a very brief answer. 1. What is the ratio of the Female students (as % of total students) in Fragile and conflict affected situations in 2004 to that in 2006?
Keep it short and to the point. 0.99. What is the ratio of the Female students (as % of total students) of Hong Kong in 2004 to that in 2006?
Make the answer very short. 1. What is the ratio of the Female students (as % of total students) in Romania in 2004 to that in 2006?
Your answer should be very brief. 1.01. What is the ratio of the Female students (as % of total students) in Fragile and conflict affected situations in 2004 to that in 2007?
Give a very brief answer. 0.98. What is the ratio of the Female students (as % of total students) of Hong Kong in 2004 to that in 2007?
Provide a succinct answer. 1. What is the ratio of the Female students (as % of total students) in Romania in 2004 to that in 2007?
Provide a succinct answer. 1.01. What is the ratio of the Female students (as % of total students) in United Arab Emirates in 2004 to that in 2007?
Give a very brief answer. 1.01. What is the ratio of the Female students (as % of total students) of Fragile and conflict affected situations in 2004 to that in 2009?
Your response must be concise. 0.98. What is the ratio of the Female students (as % of total students) in Romania in 2004 to that in 2009?
Your answer should be very brief. 1.01. What is the ratio of the Female students (as % of total students) in United Arab Emirates in 2004 to that in 2009?
Ensure brevity in your answer.  1.01. What is the ratio of the Female students (as % of total students) of Hong Kong in 2005 to that in 2006?
Keep it short and to the point. 1. What is the ratio of the Female students (as % of total students) of United Arab Emirates in 2005 to that in 2006?
Make the answer very short. 1. What is the ratio of the Female students (as % of total students) of Hong Kong in 2005 to that in 2007?
Your answer should be compact. 1. What is the ratio of the Female students (as % of total students) of Romania in 2005 to that in 2007?
Offer a terse response. 1.01. What is the ratio of the Female students (as % of total students) of Fragile and conflict affected situations in 2005 to that in 2009?
Make the answer very short. 0.99. What is the ratio of the Female students (as % of total students) of Romania in 2005 to that in 2009?
Keep it short and to the point. 1.01. What is the ratio of the Female students (as % of total students) in United Arab Emirates in 2005 to that in 2009?
Provide a succinct answer. 1.01. What is the ratio of the Female students (as % of total students) of Romania in 2006 to that in 2007?
Give a very brief answer. 1.01. What is the ratio of the Female students (as % of total students) of United Arab Emirates in 2006 to that in 2007?
Your response must be concise. 1. What is the ratio of the Female students (as % of total students) in Romania in 2006 to that in 2009?
Give a very brief answer. 1.01. What is the ratio of the Female students (as % of total students) in United Arab Emirates in 2006 to that in 2009?
Offer a terse response. 1.01. What is the ratio of the Female students (as % of total students) in Fragile and conflict affected situations in 2007 to that in 2009?
Your answer should be very brief. 1. What is the ratio of the Female students (as % of total students) in United Arab Emirates in 2007 to that in 2009?
Your answer should be compact. 1.01. What is the difference between the highest and the second highest Female students (as % of total students) of Fragile and conflict affected situations?
Make the answer very short. 0.07. What is the difference between the highest and the second highest Female students (as % of total students) of Hong Kong?
Your response must be concise. 0.04. What is the difference between the highest and the second highest Female students (as % of total students) in Romania?
Provide a succinct answer. 0.11. What is the difference between the highest and the second highest Female students (as % of total students) of United Arab Emirates?
Ensure brevity in your answer.  0.31. What is the difference between the highest and the lowest Female students (as % of total students) in Fragile and conflict affected situations?
Provide a short and direct response. 0.92. What is the difference between the highest and the lowest Female students (as % of total students) in Hong Kong?
Offer a very short reply. 0.23. What is the difference between the highest and the lowest Female students (as % of total students) in Romania?
Ensure brevity in your answer.  0.77. What is the difference between the highest and the lowest Female students (as % of total students) in United Arab Emirates?
Make the answer very short. 0.91. 